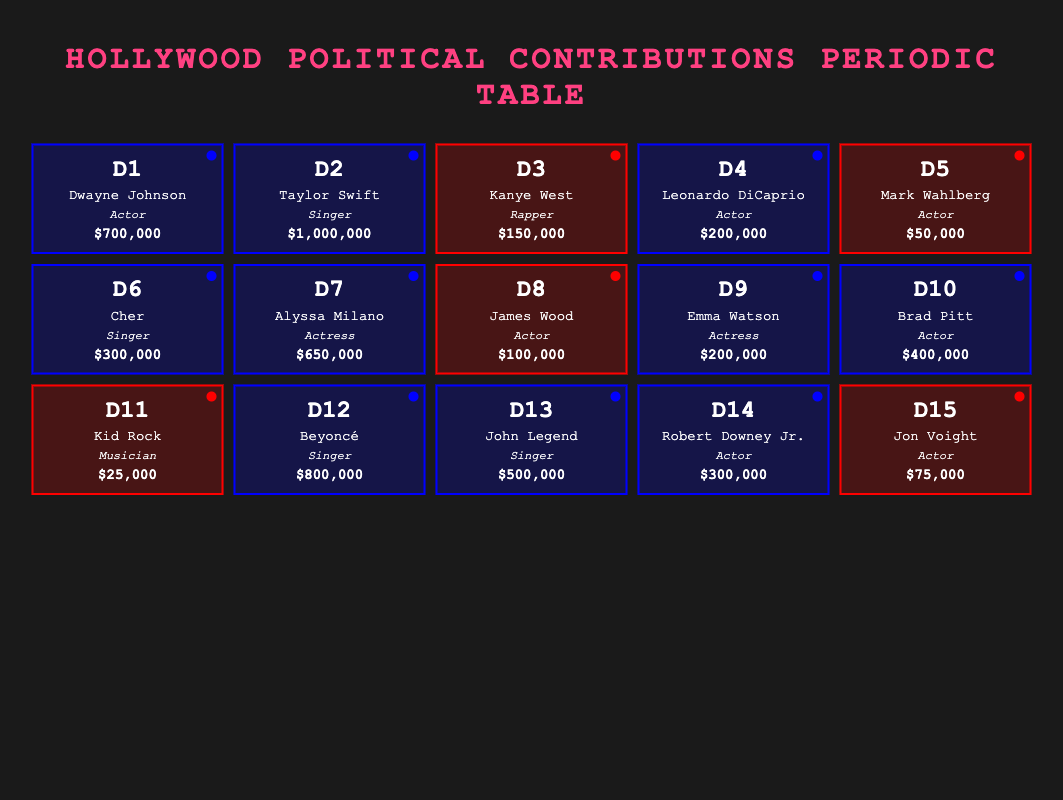What is the total contribution by all Hollywood celebrities who contributed to the Democrat Party? To find the total contribution from the Democrat Party, I sum the contributions of each Democrat listed in the table: Dwayne Johnson ($700,000) + Taylor Swift ($1,000,000) + Leonardo DiCaprio ($200,000) + Cher ($300,000) + Alyssa Milano ($650,000) + Emma Watson ($200,000) + Brad Pitt ($400,000) + Beyoncé ($800,000) + John Legend ($500,000) + Robert Downey Jr. ($300,000) = $4,750,000.
Answer: 4,750,000 Which celebrity had the highest contribution among those who donated to the Republican Party? Reviewing the table, I look for the contributions listed under Republican affiliations: Kanye West ($150,000), Mark Wahlberg ($50,000), James Wood ($100,000), Kid Rock ($25,000), and Jon Voight ($75,000). The highest contribution comes from Kanye West with $150,000.
Answer: Kanye West How many celebrities contributed more than $300,000? I check each celebrity's contribution and count those that are over $300,000: Dwayne Johnson ($700,000), Taylor Swift ($1,000,000), Beyoncé ($800,000), Alyssa Milano ($650,000), John Legend ($500,000), and Brad Pitt ($400,000), totaling six celebrities.
Answer: 6 Is it true that more celebrities contributed to the Democrat Party than the Republican Party? I count the number of celebrities for each party. There are 10 celebrities contributing to the Democrat Party and 5 contributing to the Republican Party. Since 10 is greater than 5, the statement is true.
Answer: Yes What is the average contribution of celebrities in the Republican Party? To find the average contribution for Republicans, I first sum their contributions: Kanye West ($150,000) + Mark Wahlberg ($50,000) + James Wood ($100,000) + Kid Rock ($25,000) + Jon Voight ($75,000) = $400,000. There are 5 Republicans, so the average is $400,000 / 5 = $80,000.
Answer: 80,000 Which actor had the second-highest contribution overall? First, I list the contributions by actors: Dwayne Johnson ($700,000), Brad Pitt ($400,000), Leonardo DiCaprio ($200,000), Robert Downey Jr. ($300,000), Mark Wahlberg ($50,000), James Wood ($100,000), and Jon Voight ($75,000). Sorting from highest to lowest, Dwayne Johnson is first, followed by Brad Pitt with $400,000.
Answer: Brad Pitt How much more did Taylor Swift contribute than Dwayne Johnson? I subtract Dwayne Johnson’s contribution from Taylor Swift’s: Taylor Swift ($1,000,000) - Dwayne Johnson ($700,000) gives $300,000.
Answer: 300,000 Are there any celebrities who contributed less than $50,000? I check the contributions listed, and the lowest is Kid Rock ($25,000), which is less than $50,000. Therefore, the answer is yes.
Answer: Yes 